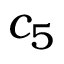<formula> <loc_0><loc_0><loc_500><loc_500>c _ { 5 }</formula> 